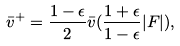<formula> <loc_0><loc_0><loc_500><loc_500>\bar { v } ^ { + } = \frac { 1 - \epsilon } { 2 } \bar { v } ( \frac { 1 + \epsilon } { 1 - \epsilon } | F | ) ,</formula> 